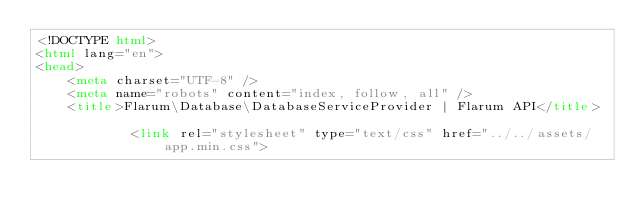Convert code to text. <code><loc_0><loc_0><loc_500><loc_500><_HTML_><!DOCTYPE html>
<html lang="en">
<head>
    <meta charset="UTF-8" />
    <meta name="robots" content="index, follow, all" />
    <title>Flarum\Database\DatabaseServiceProvider | Flarum API</title>

            <link rel="stylesheet" type="text/css" href="../../assets/app.min.css"></code> 